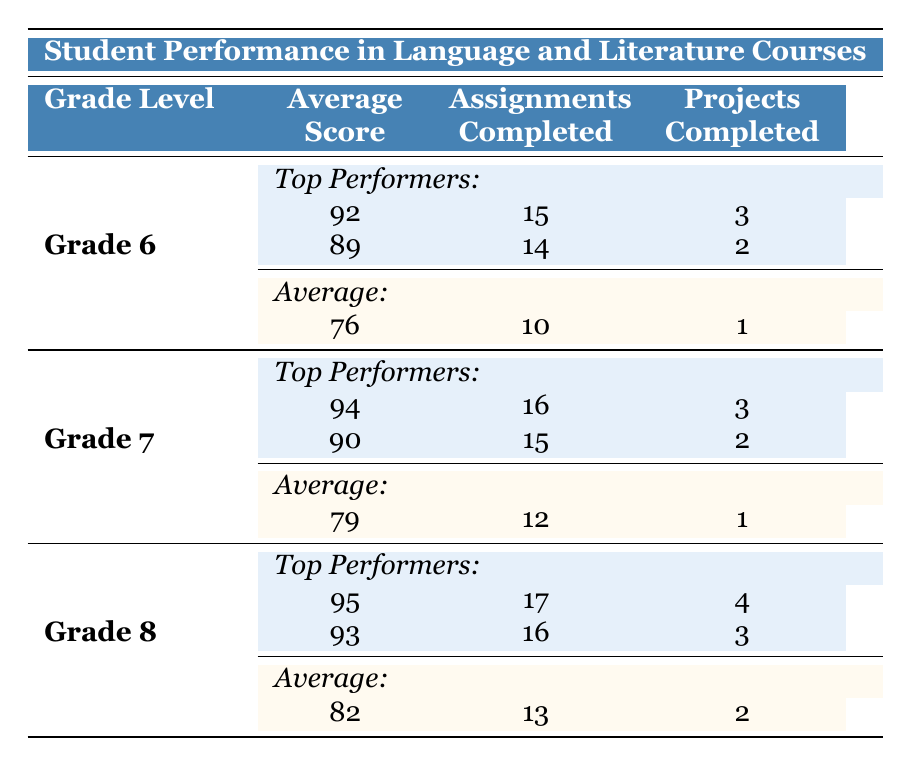What is the average score of students in Grade 6? The table lists an average score of 76 under Grade 6.
Answer: 76 Who are the top performers in Grade 7? The top performers listed for Grade 7 are Emma White with an average score of 94 and James Smith with an average score of 90.
Answer: Emma White and James Smith How many total students are there in Grade 8? The total number of students in Grade 8 is stated as 25 in the average performance section.
Answer: 25 What is the difference in average scores between Grade 6 and Grade 8? The average score for Grade 6 is 76 and for Grade 8 is 82. The difference is 82 - 76 = 6.
Answer: 6 Did any student in Grade 7 complete more projects than the average? The average number of projects completed in Grade 7 is 1. Emma White (3 projects) and James Smith (2 projects) both completed more projects than the average.
Answer: Yes What is the average number of assignments completed in Grade 6? Under the average performance for Grade 6, it is noted that the average number of assignments completed is 10.
Answer: 10 Which low performer in Grade 6 had the highest average score? The low performers in Grade 6 are Jessica Green with an average score of 65 and David Wilson with an average score of 68. David Wilson has the higher average score.
Answer: David Wilson How many projects did Oliver Martinez complete in comparison to the average in Grade 8? Oliver Martinez completed 4 projects, while the average number of projects completed in Grade 8 is 2. Therefore, he completed 2 more projects than the average.
Answer: 2 more projects Are there more top performers in Grade 8 than Grade 6? Grade 8 has 2 top performers (Oliver Martinez and Ava Clark) while Grade 6 also has 2 top performers (Alice Johnson and Michael Brown). Thus, they are equal in the number of top performers.
Answer: No 